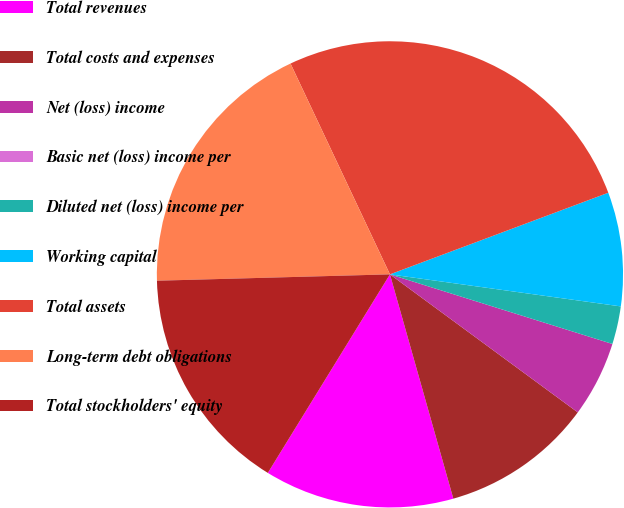Convert chart. <chart><loc_0><loc_0><loc_500><loc_500><pie_chart><fcel>Total revenues<fcel>Total costs and expenses<fcel>Net (loss) income<fcel>Basic net (loss) income per<fcel>Diluted net (loss) income per<fcel>Working capital<fcel>Total assets<fcel>Long-term debt obligations<fcel>Total stockholders' equity<nl><fcel>13.16%<fcel>10.53%<fcel>5.26%<fcel>0.0%<fcel>2.63%<fcel>7.89%<fcel>26.32%<fcel>18.42%<fcel>15.79%<nl></chart> 